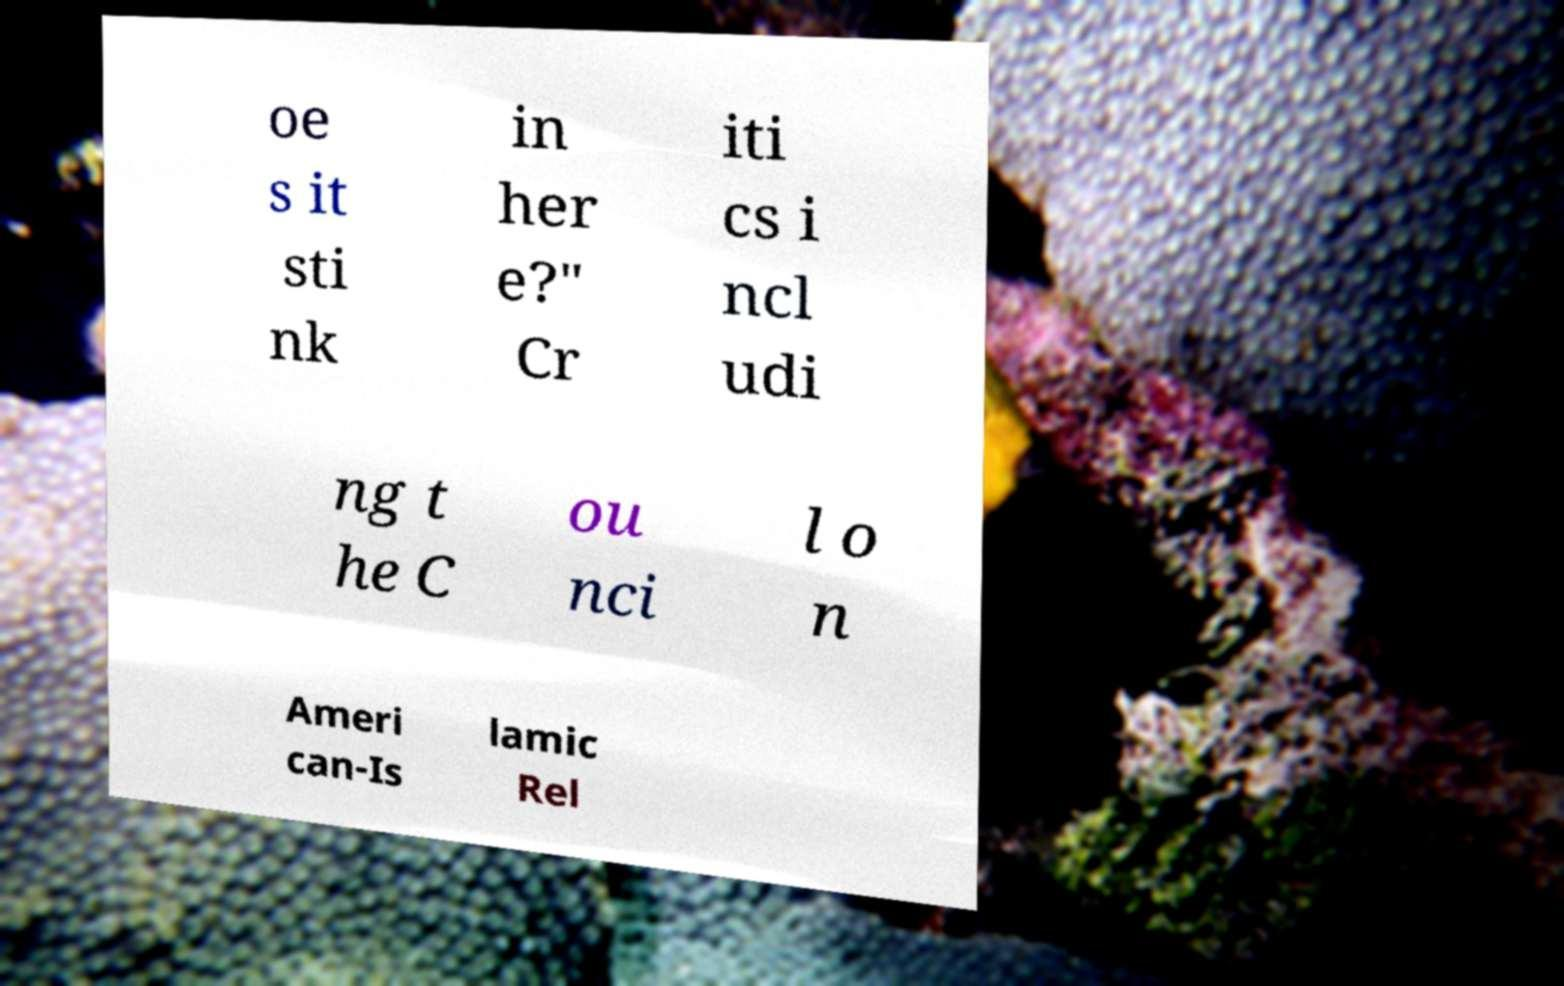For documentation purposes, I need the text within this image transcribed. Could you provide that? oe s it sti nk in her e?" Cr iti cs i ncl udi ng t he C ou nci l o n Ameri can-Is lamic Rel 